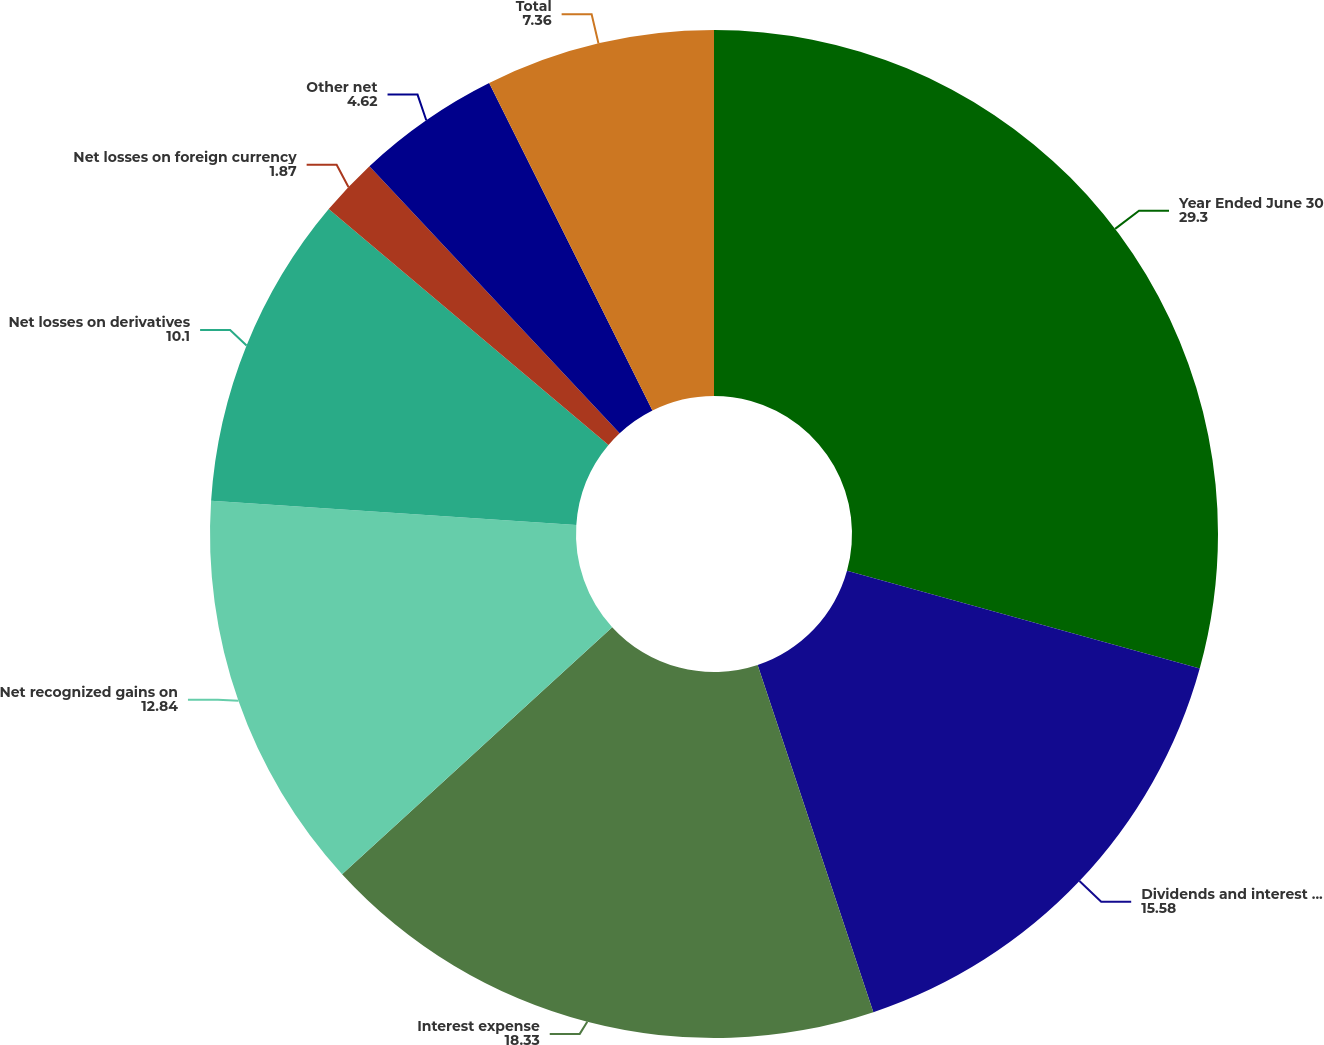Convert chart to OTSL. <chart><loc_0><loc_0><loc_500><loc_500><pie_chart><fcel>Year Ended June 30<fcel>Dividends and interest income<fcel>Interest expense<fcel>Net recognized gains on<fcel>Net losses on derivatives<fcel>Net losses on foreign currency<fcel>Other net<fcel>Total<nl><fcel>29.3%<fcel>15.58%<fcel>18.33%<fcel>12.84%<fcel>10.1%<fcel>1.87%<fcel>4.62%<fcel>7.36%<nl></chart> 